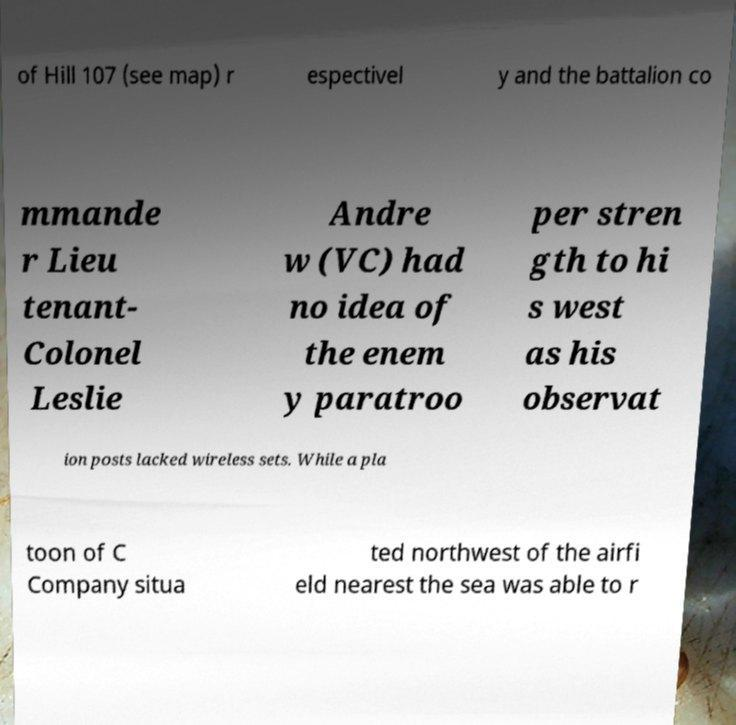I need the written content from this picture converted into text. Can you do that? of Hill 107 (see map) r espectivel y and the battalion co mmande r Lieu tenant- Colonel Leslie Andre w (VC) had no idea of the enem y paratroo per stren gth to hi s west as his observat ion posts lacked wireless sets. While a pla toon of C Company situa ted northwest of the airfi eld nearest the sea was able to r 